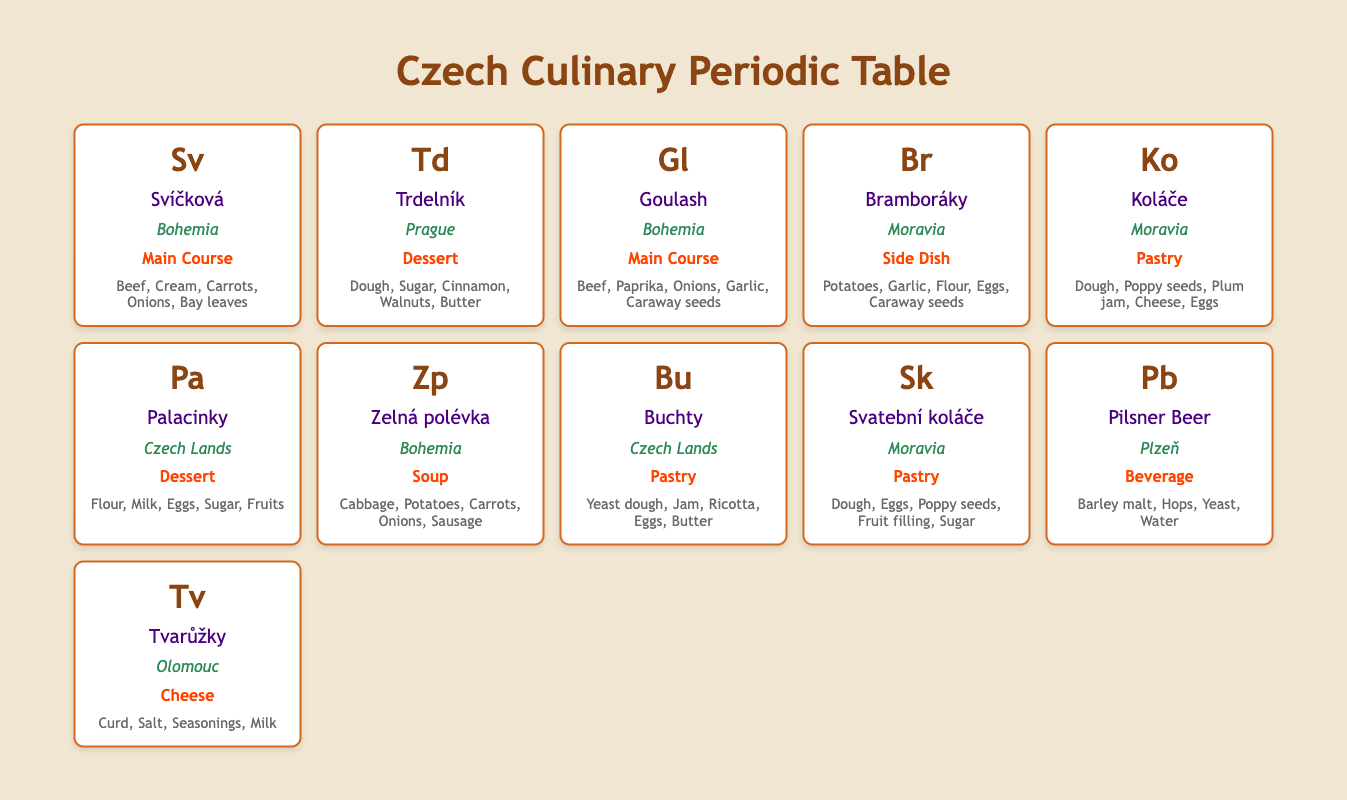What dish from Moravia contains potatoes? The table lists Moravian dishes, and looking specifically at the "ingredients" section for dishes in the Moravia region, I see "Bramboráky," which features potatoes among its ingredients.
Answer: Bramboráky Which dessert is associated with Prague? The table shows Trdelník as a dessert from Prague. It is labeled clearly, and its category is Dessert.
Answer: Trdelník How many main courses are listed from Bohemia? By reviewing the table, I find two main courses labeled from the Bohemia region: Svíčková and Goulash. I count them to confirm there are two entries.
Answer: 2 Is Pilsner Beer classified as a pastry? Referring to the category listed in the table, Pilsner Beer is categorized as a beverage, not a pastry. Thus, the statement is false.
Answer: No What are the main ingredients in Goulash? The ingredients for Goulash are clearly listed in the table, which includes Beef, Paprika, Onions, Garlic, and Caraway seeds.
Answer: Beef, Paprika, Onions, Garlic, Caraway seeds How many total pastries are listed in Moravia? The table highlights two pastries from Moravia: Koláče and Svatební koláče. Counting these gives a total of two pastries in that region.
Answer: 2 What is the main ingredient in Tvarůžky? The table provides Tvarůžky details, indicating that the main ingredient is Curd. This information is directly obtainable from the ingredients section.
Answer: Curd Which dish from Czech Lands has jam as an ingredient? The table shows Buchty from Czech Lands, which lists jam among its ingredients. This requires checking the ingredients of the relevant dish.
Answer: Buchty How many categories of dishes are represented in the table? I analyze the table to count unique categories mentioned, including Main Course, Dessert, Side Dish, Pastry, Soup, Beverage, and Cheese. This counts to seven distinct categories.
Answer: 7 